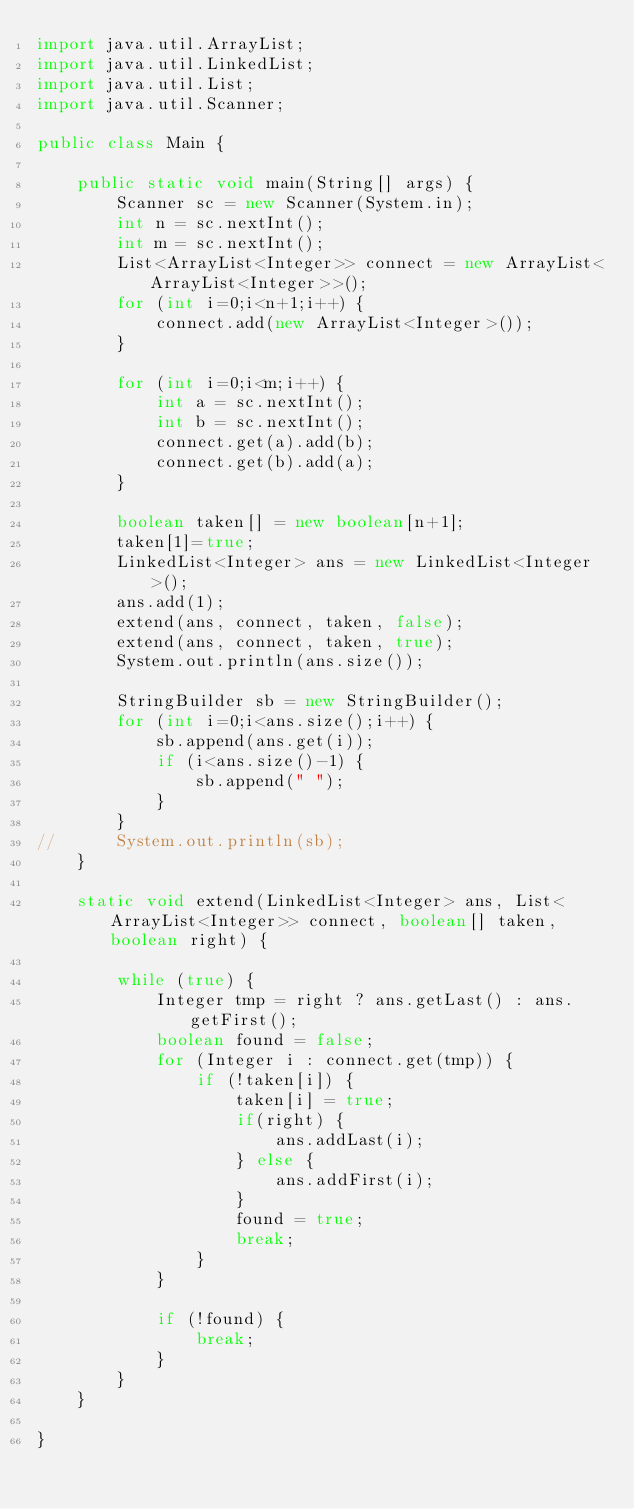Convert code to text. <code><loc_0><loc_0><loc_500><loc_500><_Java_>import java.util.ArrayList;
import java.util.LinkedList;
import java.util.List;
import java.util.Scanner;

public class Main {

	public static void main(String[] args) {
		Scanner sc = new Scanner(System.in);
		int n = sc.nextInt();
		int m = sc.nextInt();
		List<ArrayList<Integer>> connect = new ArrayList<ArrayList<Integer>>();
		for (int i=0;i<n+1;i++) {
			connect.add(new ArrayList<Integer>());
		}

		for (int i=0;i<m;i++) {
			int a = sc.nextInt();
			int b = sc.nextInt();
			connect.get(a).add(b);
			connect.get(b).add(a);
		}

		boolean taken[] = new boolean[n+1];
		taken[1]=true;
		LinkedList<Integer> ans = new LinkedList<Integer>();
		ans.add(1);
		extend(ans, connect, taken, false);
		extend(ans, connect, taken, true);
		System.out.println(ans.size());

		StringBuilder sb = new StringBuilder();
		for (int i=0;i<ans.size();i++) {
			sb.append(ans.get(i));
			if (i<ans.size()-1) {
				sb.append(" ");
			}
		}
//		System.out.println(sb);
	}

	static void extend(LinkedList<Integer> ans, List<ArrayList<Integer>> connect, boolean[] taken, boolean right) {

		while (true) {
			Integer tmp = right ? ans.getLast() : ans.getFirst();
			boolean found = false;
			for (Integer i : connect.get(tmp)) {
				if (!taken[i]) {
					taken[i] = true;
					if(right) {
						ans.addLast(i);
					} else {
						ans.addFirst(i);
					}
					found = true;
					break;
				}
			}

			if (!found) {
				break;
			}
		}
	}

}
</code> 